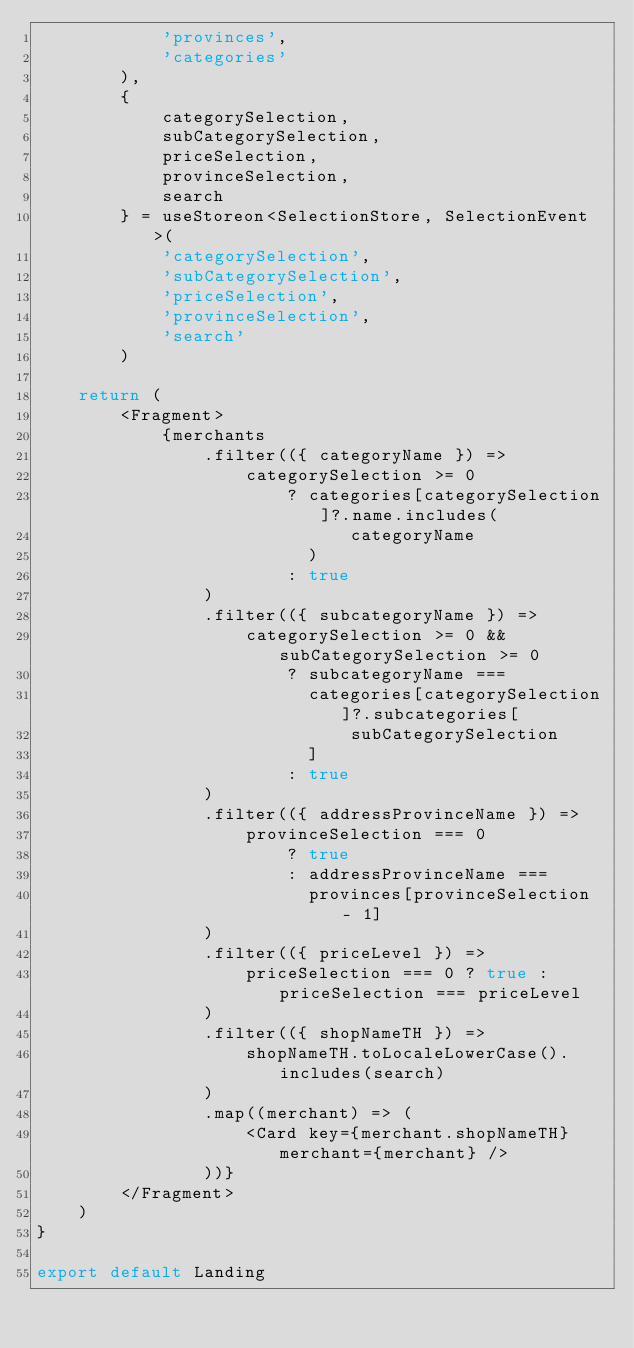<code> <loc_0><loc_0><loc_500><loc_500><_TypeScript_>            'provinces',
            'categories'
        ),
        {
            categorySelection,
            subCategorySelection,
            priceSelection,
            provinceSelection,
            search
        } = useStoreon<SelectionStore, SelectionEvent>(
            'categorySelection',
            'subCategorySelection',
            'priceSelection',
            'provinceSelection',
            'search'
        )

    return (
        <Fragment>
            {merchants
                .filter(({ categoryName }) =>
                    categorySelection >= 0
                        ? categories[categorySelection]?.name.includes(
                              categoryName
                          )
                        : true
                )
                .filter(({ subcategoryName }) =>
                    categorySelection >= 0 && subCategorySelection >= 0
                        ? subcategoryName ===
                          categories[categorySelection]?.subcategories[
                              subCategorySelection
                          ]
                        : true
                )
                .filter(({ addressProvinceName }) =>
                    provinceSelection === 0
                        ? true
                        : addressProvinceName ===
                          provinces[provinceSelection - 1]
                )
                .filter(({ priceLevel }) =>
                    priceSelection === 0 ? true : priceSelection === priceLevel
                )
                .filter(({ shopNameTH }) =>
                    shopNameTH.toLocaleLowerCase().includes(search)
                )
                .map((merchant) => (
                    <Card key={merchant.shopNameTH} merchant={merchant} />
                ))}
        </Fragment>
    )
}

export default Landing
</code> 